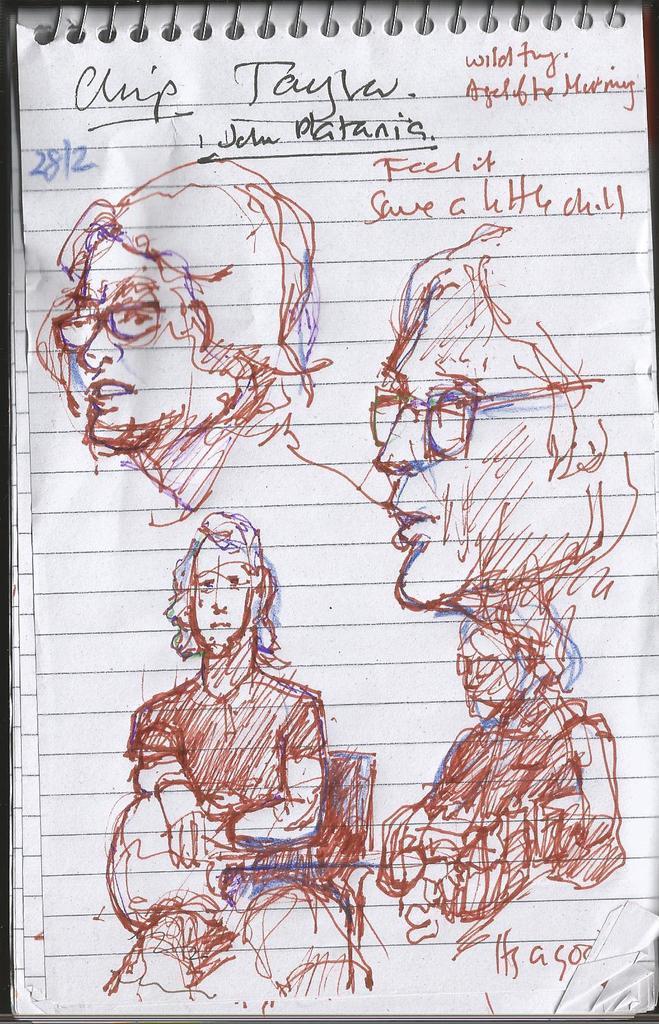Can you describe this image briefly? In this picture we can see a spiral binding book, we can see sketches of persons and handwritten text on this book. 